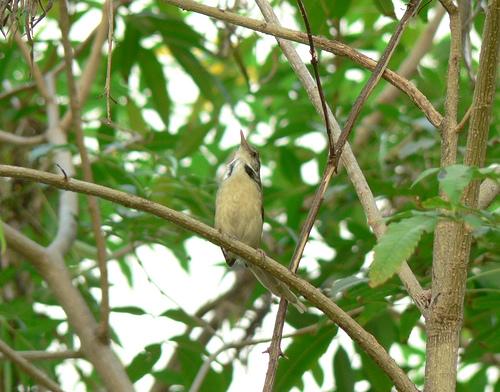What kind of line are the birds sitting on?
Keep it brief. Branch. What season does it seem to be?
Keep it brief. Summer. What species of bird is this?
Answer briefly. Kingfisher. Is the bird looking up or down?
Quick response, please. Up. Did this bird just land?
Answer briefly. Yes. What is the main color of the bird?
Short answer required. Yellow. 